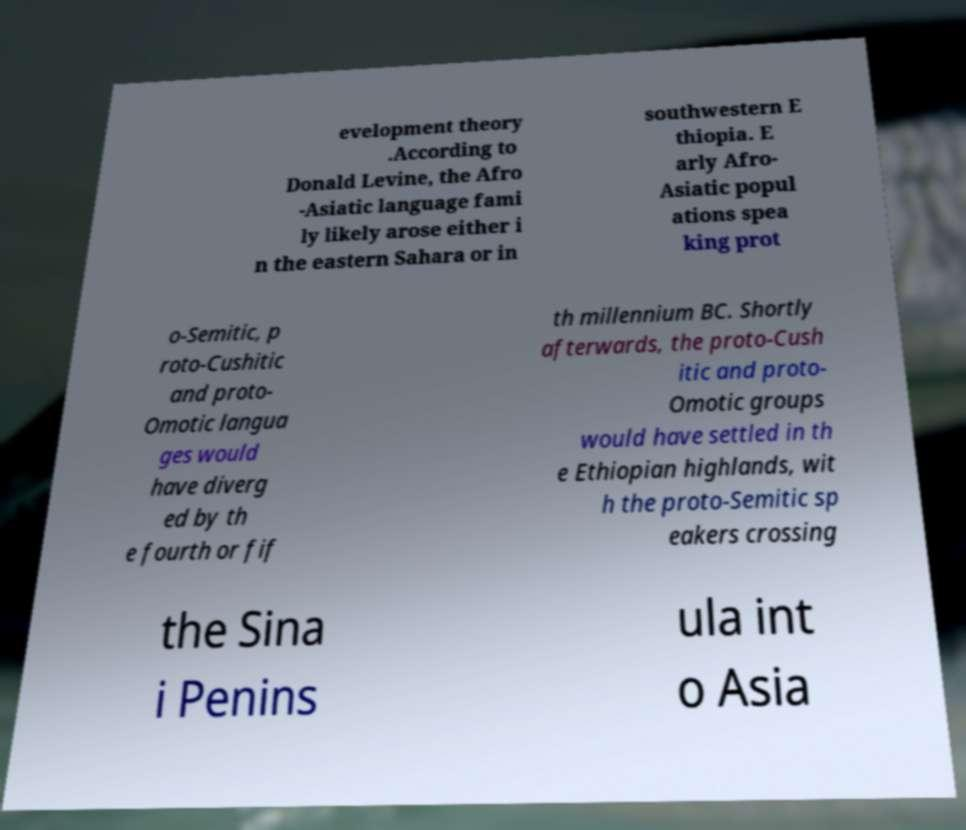Please read and relay the text visible in this image. What does it say? evelopment theory .According to Donald Levine, the Afro -Asiatic language fami ly likely arose either i n the eastern Sahara or in southwestern E thiopia. E arly Afro- Asiatic popul ations spea king prot o-Semitic, p roto-Cushitic and proto- Omotic langua ges would have diverg ed by th e fourth or fif th millennium BC. Shortly afterwards, the proto-Cush itic and proto- Omotic groups would have settled in th e Ethiopian highlands, wit h the proto-Semitic sp eakers crossing the Sina i Penins ula int o Asia 